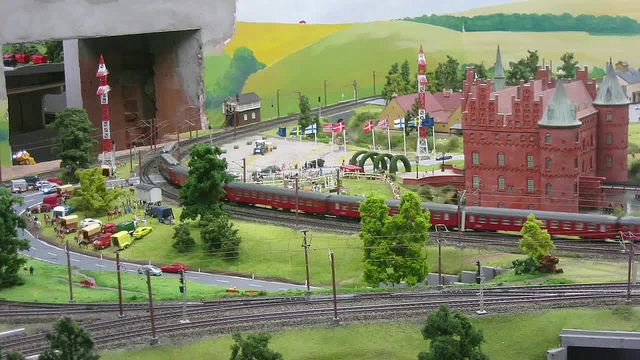Describe the buildings visible in the background. The image features multiple buildings including a large, ornate red building that resembles a traditional European castle. Additionally, there are smaller structures that look like typical townhouses, contributing to the scene’s diverse architectural style, suggesting a European town setting in the model. What details can you tell about the castle-like building? The red building resembling a castle features intricate detailing suggestive of Gothic architecture, with pointed arches and a turret. It adds a historic touch to the miniature landscape, standing out among the other more modern architectural elements. 